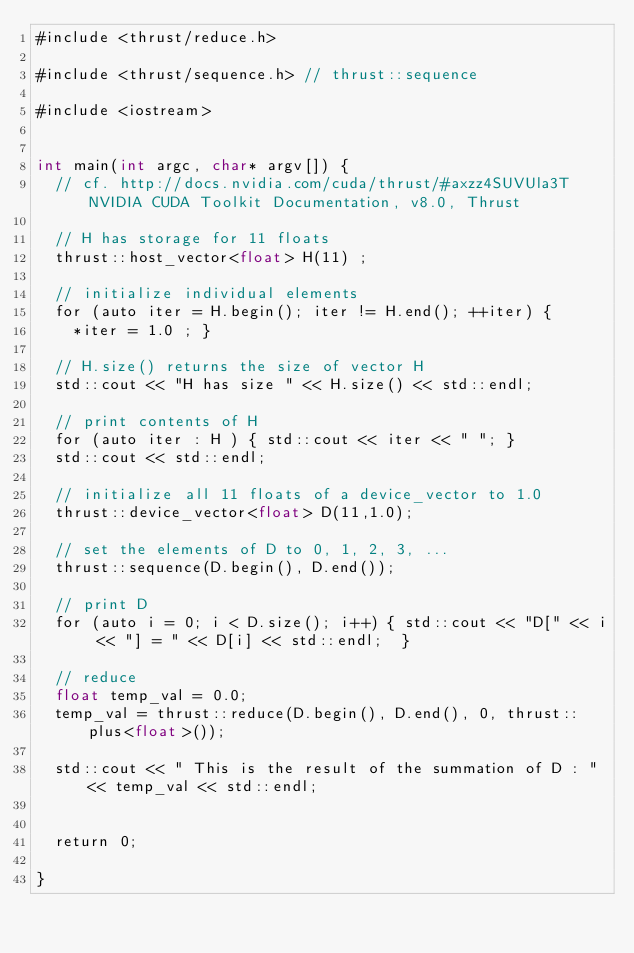<code> <loc_0><loc_0><loc_500><loc_500><_Cuda_>#include <thrust/reduce.h>

#include <thrust/sequence.h> // thrust::sequence

#include <iostream>


int main(int argc, char* argv[]) {
	// cf. http://docs.nvidia.com/cuda/thrust/#axzz4SUVUla3T  NVIDIA CUDA Toolkit Documentation, v8.0, Thrust
	
	// H has storage for 11 floats
	thrust::host_vector<float> H(11) ;
	
	// initialize individual elements
	for (auto iter = H.begin(); iter != H.end(); ++iter) {
		*iter = 1.0 ; }
	
	// H.size() returns the size of vector H
	std::cout << "H has size " << H.size() << std::endl;
	
	// print contents of H
	for (auto iter : H ) { std::cout << iter << " "; } 
	std::cout << std::endl; 
	
	// initialize all 11 floats of a device_vector to 1.0
	thrust::device_vector<float> D(11,1.0);
	
	// set the elements of D to 0, 1, 2, 3, ...
	thrust::sequence(D.begin(), D.end());
	
	// print D
	for (auto i = 0; i < D.size(); i++) { std::cout << "D[" << i << "] = " << D[i] << std::endl;  }
		
	// reduce
	float temp_val = 0.0;
	temp_val = thrust::reduce(D.begin(), D.end(), 0, thrust::plus<float>());
		
	std::cout << " This is the result of the summation of D : " << temp_val << std::endl; 
	
		
	return 0;
	
}

</code> 